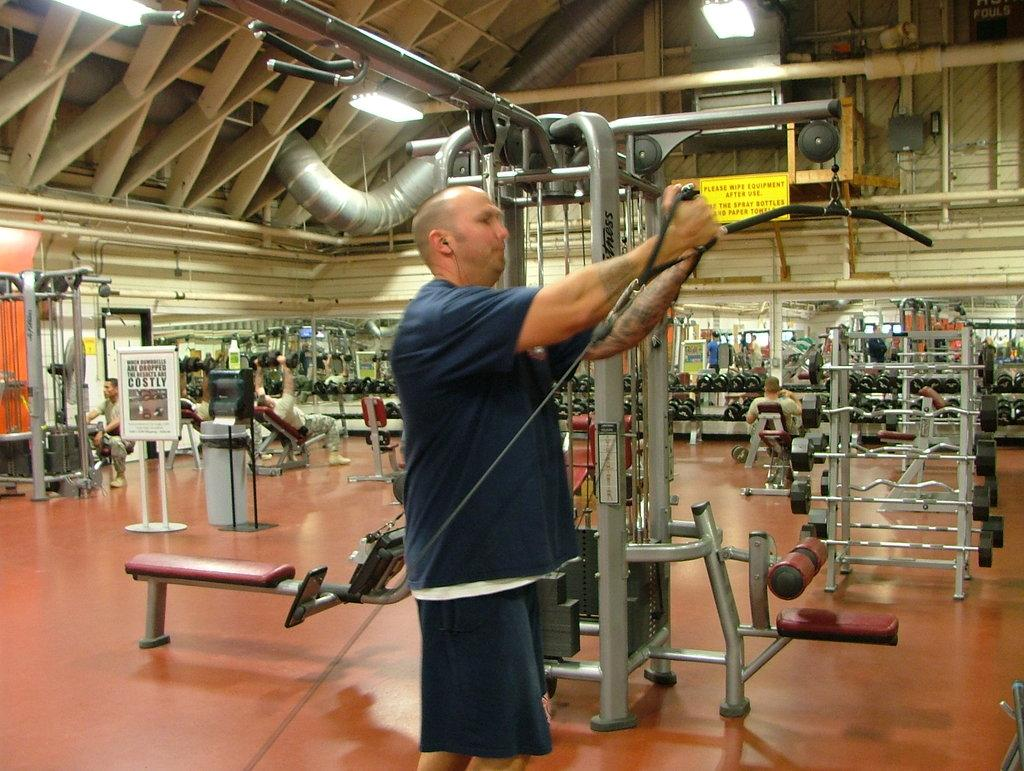What is the person in the image holding? The person is holding a gym equipment. What can be seen in the background of the image? There are many gym equipment in the background. How many people are present in the image? There are people in the image. What type of lighting is present in the image? There are lights on the ceiling. How many geese are present in the image? There are no geese present in the image. What type of yak can be seen interacting with the gym equipment in the image? There is no yak present in the image; it features a person holding gym equipment and other people in a gym setting. 